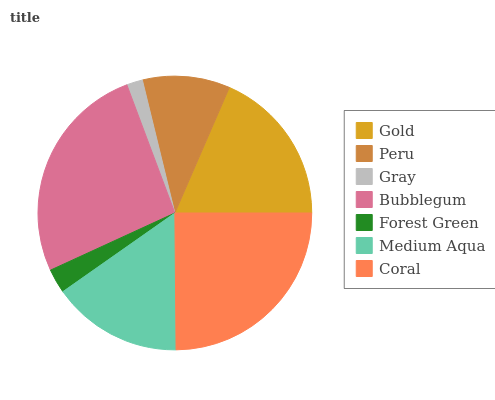Is Gray the minimum?
Answer yes or no. Yes. Is Bubblegum the maximum?
Answer yes or no. Yes. Is Peru the minimum?
Answer yes or no. No. Is Peru the maximum?
Answer yes or no. No. Is Gold greater than Peru?
Answer yes or no. Yes. Is Peru less than Gold?
Answer yes or no. Yes. Is Peru greater than Gold?
Answer yes or no. No. Is Gold less than Peru?
Answer yes or no. No. Is Medium Aqua the high median?
Answer yes or no. Yes. Is Medium Aqua the low median?
Answer yes or no. Yes. Is Peru the high median?
Answer yes or no. No. Is Forest Green the low median?
Answer yes or no. No. 